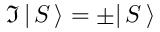Convert formula to latex. <formula><loc_0><loc_0><loc_500><loc_500>{ \mathfrak { I } } \, | \, S \, \rangle = \pm | \, S \, \rangle</formula> 